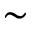<formula> <loc_0><loc_0><loc_500><loc_500>\sim</formula> 